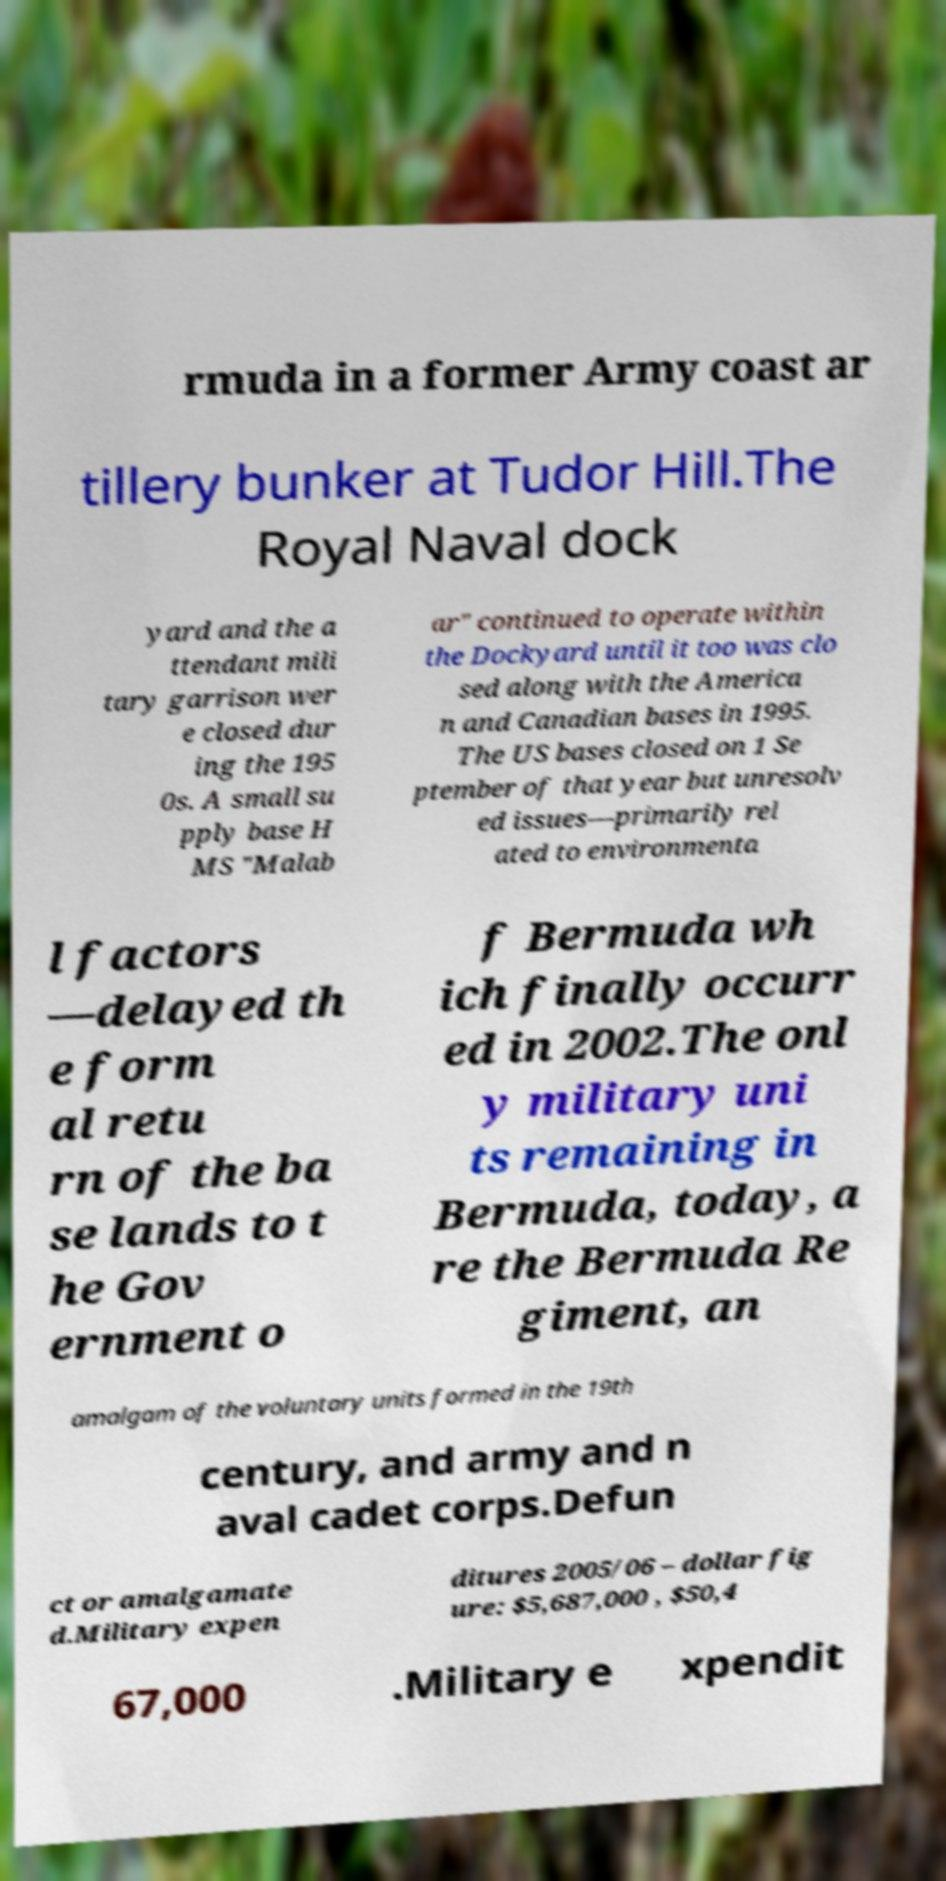Please read and relay the text visible in this image. What does it say? rmuda in a former Army coast ar tillery bunker at Tudor Hill.The Royal Naval dock yard and the a ttendant mili tary garrison wer e closed dur ing the 195 0s. A small su pply base H MS "Malab ar" continued to operate within the Dockyard until it too was clo sed along with the America n and Canadian bases in 1995. The US bases closed on 1 Se ptember of that year but unresolv ed issues—primarily rel ated to environmenta l factors —delayed th e form al retu rn of the ba se lands to t he Gov ernment o f Bermuda wh ich finally occurr ed in 2002.The onl y military uni ts remaining in Bermuda, today, a re the Bermuda Re giment, an amalgam of the voluntary units formed in the 19th century, and army and n aval cadet corps.Defun ct or amalgamate d.Military expen ditures 2005/06 – dollar fig ure: $5,687,000 , $50,4 67,000 .Military e xpendit 